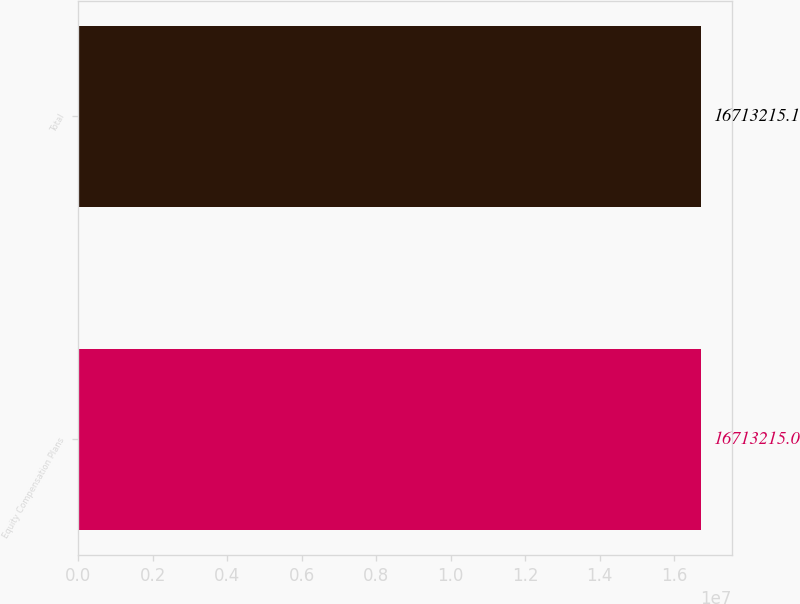Convert chart. <chart><loc_0><loc_0><loc_500><loc_500><bar_chart><fcel>Equity Compensation Plans<fcel>Total<nl><fcel>1.67132e+07<fcel>1.67132e+07<nl></chart> 